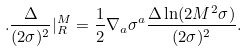<formula> <loc_0><loc_0><loc_500><loc_500>. \frac { \Delta } { ( 2 \sigma ) ^ { 2 } } | _ { R } ^ { M } = \frac { 1 } { 2 } \nabla _ { a } \sigma ^ { a } \frac { \Delta \ln ( 2 M ^ { 2 } \sigma ) } { ( 2 \sigma ) ^ { 2 } } .</formula> 